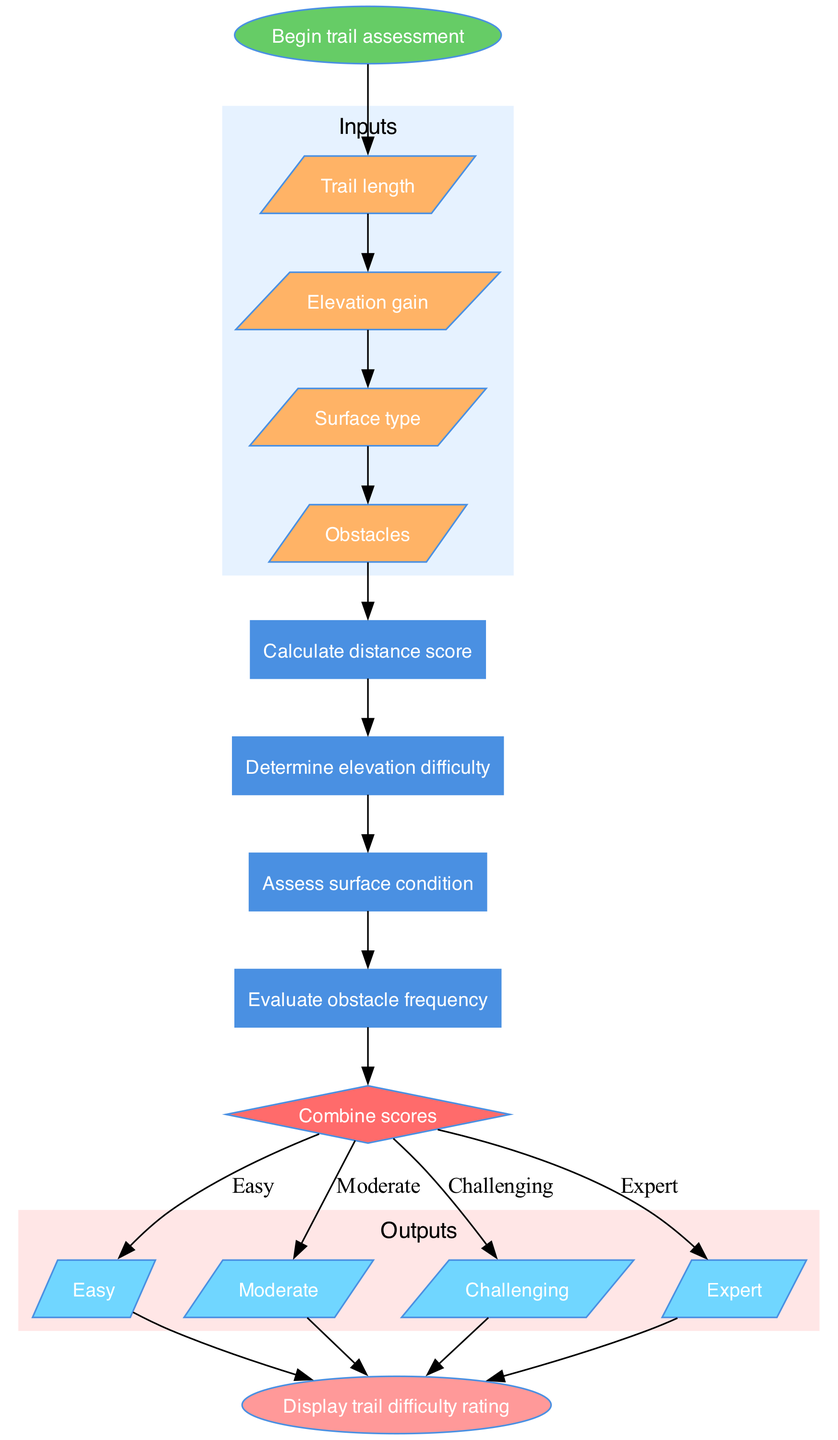What is the starting point of the trail assessment process? The diagram shows that the assessment begins with the node labeled "Begin trail assessment." This is indicated as the starting point in the flowchart before any inputs or processes take place.
Answer: Begin trail assessment How many processes are involved in the trail difficulty rating calculation? By counting the nodes listed under the "processes" section of the diagram, we see there are four distinct processes: "Calculate distance score," "Determine elevation difficulty," "Assess surface condition," and "Evaluate obstacle frequency." This totals to four processes.
Answer: Four What is the decision node in the flowchart? The diagram identifies the decision node as "Combine scores." It is depicted as a diamond shape, which is typical for decision nodes in flowcharts, indicating that this is where the assessment reaches a conclusion based on the earlier computed scores.
Answer: Combine scores What are the output categories of the trail difficulty rating? The outputs are displayed in a cluster labeled "Outputs," which lists four categories: "Easy," "Moderate," "Challenging," and "Expert." These represent the different levels of trail difficulty ratings concluded from the assessment process.
Answer: Easy, Moderate, Challenging, Expert What follows after assessing surface condition? After the process of "Assess surface condition," the flowchart indicates an edge leading to the "Evaluate obstacle frequency" process. This means that once surface conditions are evaluated, the next step is to assess obstacles found on the trail.
Answer: Evaluate obstacle frequency Which input is processed first in the sequence? According to the flowchart, the first input node connected after the start node is labeled "Trail length." This establishes the initial data point needed to begin the trail difficulty assessment.
Answer: Trail length What is the shape of the end node in the diagram? The end node is represented with an oval shape filled with a specific color. This is typical for indicating the termination point of a process in a flowchart and is clearly labeled as "Display trail difficulty rating."
Answer: Oval 